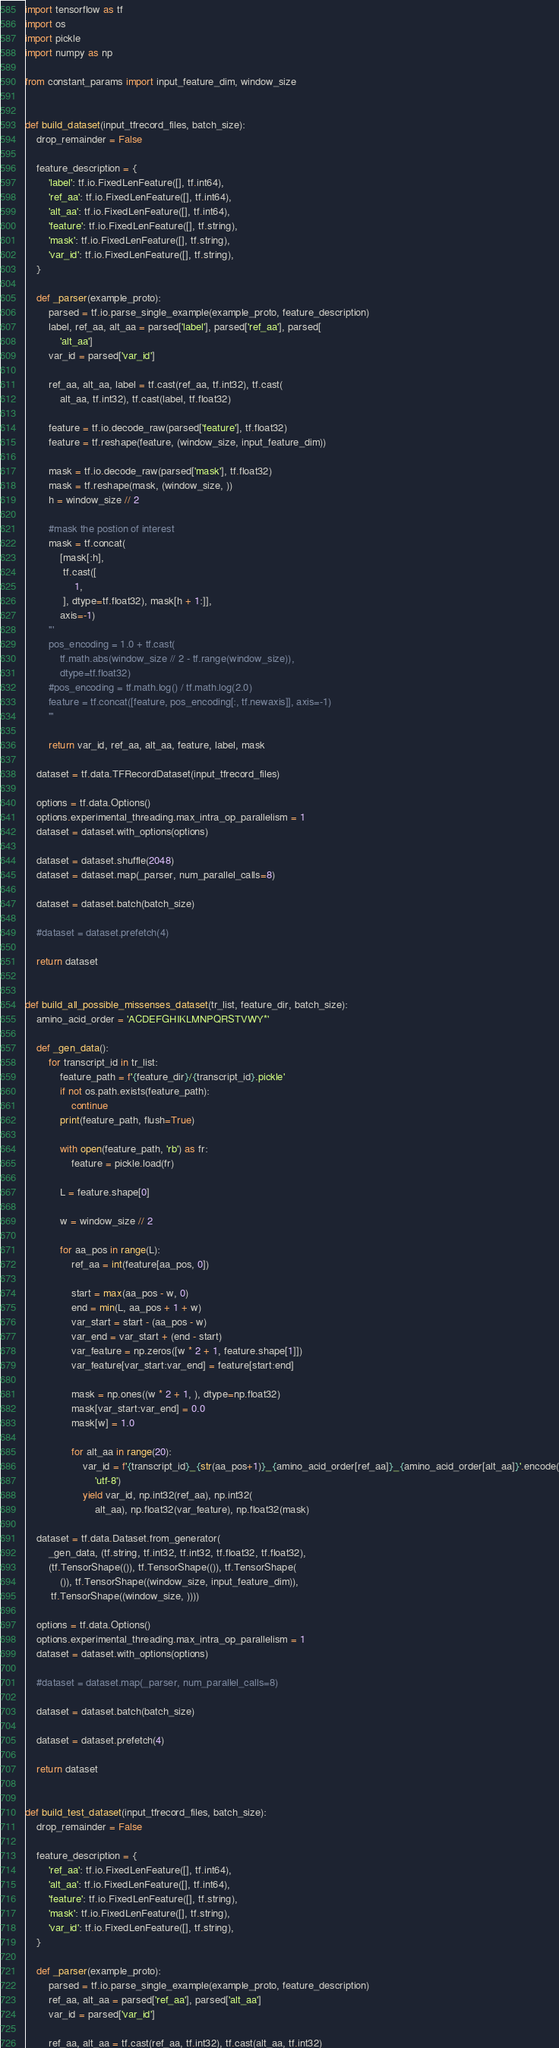Convert code to text. <code><loc_0><loc_0><loc_500><loc_500><_Python_>import tensorflow as tf
import os
import pickle
import numpy as np

from constant_params import input_feature_dim, window_size


def build_dataset(input_tfrecord_files, batch_size):
    drop_remainder = False

    feature_description = {
        'label': tf.io.FixedLenFeature([], tf.int64),
        'ref_aa': tf.io.FixedLenFeature([], tf.int64),
        'alt_aa': tf.io.FixedLenFeature([], tf.int64),
        'feature': tf.io.FixedLenFeature([], tf.string),
        'mask': tf.io.FixedLenFeature([], tf.string),
        'var_id': tf.io.FixedLenFeature([], tf.string),
    }

    def _parser(example_proto):
        parsed = tf.io.parse_single_example(example_proto, feature_description)
        label, ref_aa, alt_aa = parsed['label'], parsed['ref_aa'], parsed[
            'alt_aa']
        var_id = parsed['var_id']

        ref_aa, alt_aa, label = tf.cast(ref_aa, tf.int32), tf.cast(
            alt_aa, tf.int32), tf.cast(label, tf.float32)

        feature = tf.io.decode_raw(parsed['feature'], tf.float32)
        feature = tf.reshape(feature, (window_size, input_feature_dim))

        mask = tf.io.decode_raw(parsed['mask'], tf.float32)
        mask = tf.reshape(mask, (window_size, ))
        h = window_size // 2

        #mask the postion of interest
        mask = tf.concat(
            [mask[:h],
             tf.cast([
                 1,
             ], dtype=tf.float32), mask[h + 1:]],
            axis=-1)
        '''
        pos_encoding = 1.0 + tf.cast(
            tf.math.abs(window_size // 2 - tf.range(window_size)),
            dtype=tf.float32)
        #pos_encoding = tf.math.log() / tf.math.log(2.0)
        feature = tf.concat([feature, pos_encoding[:, tf.newaxis]], axis=-1)
        '''

        return var_id, ref_aa, alt_aa, feature, label, mask

    dataset = tf.data.TFRecordDataset(input_tfrecord_files)

    options = tf.data.Options()
    options.experimental_threading.max_intra_op_parallelism = 1
    dataset = dataset.with_options(options)

    dataset = dataset.shuffle(2048)
    dataset = dataset.map(_parser, num_parallel_calls=8)

    dataset = dataset.batch(batch_size)

    #dataset = dataset.prefetch(4)

    return dataset


def build_all_possible_missenses_dataset(tr_list, feature_dir, batch_size):
    amino_acid_order = 'ACDEFGHIKLMNPQRSTVWY*'

    def _gen_data():
        for transcript_id in tr_list:
            feature_path = f'{feature_dir}/{transcript_id}.pickle'
            if not os.path.exists(feature_path):
                continue
            print(feature_path, flush=True)

            with open(feature_path, 'rb') as fr:
                feature = pickle.load(fr)

            L = feature.shape[0]

            w = window_size // 2

            for aa_pos in range(L):
                ref_aa = int(feature[aa_pos, 0])

                start = max(aa_pos - w, 0)
                end = min(L, aa_pos + 1 + w)
                var_start = start - (aa_pos - w)
                var_end = var_start + (end - start)
                var_feature = np.zeros([w * 2 + 1, feature.shape[1]])
                var_feature[var_start:var_end] = feature[start:end]

                mask = np.ones((w * 2 + 1, ), dtype=np.float32)
                mask[var_start:var_end] = 0.0
                mask[w] = 1.0

                for alt_aa in range(20):
                    var_id = f'{transcript_id}_{str(aa_pos+1)}_{amino_acid_order[ref_aa]}_{amino_acid_order[alt_aa]}'.encode(
                        'utf-8')
                    yield var_id, np.int32(ref_aa), np.int32(
                        alt_aa), np.float32(var_feature), np.float32(mask)

    dataset = tf.data.Dataset.from_generator(
        _gen_data, (tf.string, tf.int32, tf.int32, tf.float32, tf.float32),
        (tf.TensorShape(()), tf.TensorShape(()), tf.TensorShape(
            ()), tf.TensorShape((window_size, input_feature_dim)),
         tf.TensorShape((window_size, ))))

    options = tf.data.Options()
    options.experimental_threading.max_intra_op_parallelism = 1
    dataset = dataset.with_options(options)

    #dataset = dataset.map(_parser, num_parallel_calls=8)

    dataset = dataset.batch(batch_size)

    dataset = dataset.prefetch(4)

    return dataset


def build_test_dataset(input_tfrecord_files, batch_size):
    drop_remainder = False

    feature_description = {
        'ref_aa': tf.io.FixedLenFeature([], tf.int64),
        'alt_aa': tf.io.FixedLenFeature([], tf.int64),
        'feature': tf.io.FixedLenFeature([], tf.string),
        'mask': tf.io.FixedLenFeature([], tf.string),
        'var_id': tf.io.FixedLenFeature([], tf.string),
    }

    def _parser(example_proto):
        parsed = tf.io.parse_single_example(example_proto, feature_description)
        ref_aa, alt_aa = parsed['ref_aa'], parsed['alt_aa']
        var_id = parsed['var_id']

        ref_aa, alt_aa = tf.cast(ref_aa, tf.int32), tf.cast(alt_aa, tf.int32)
</code> 